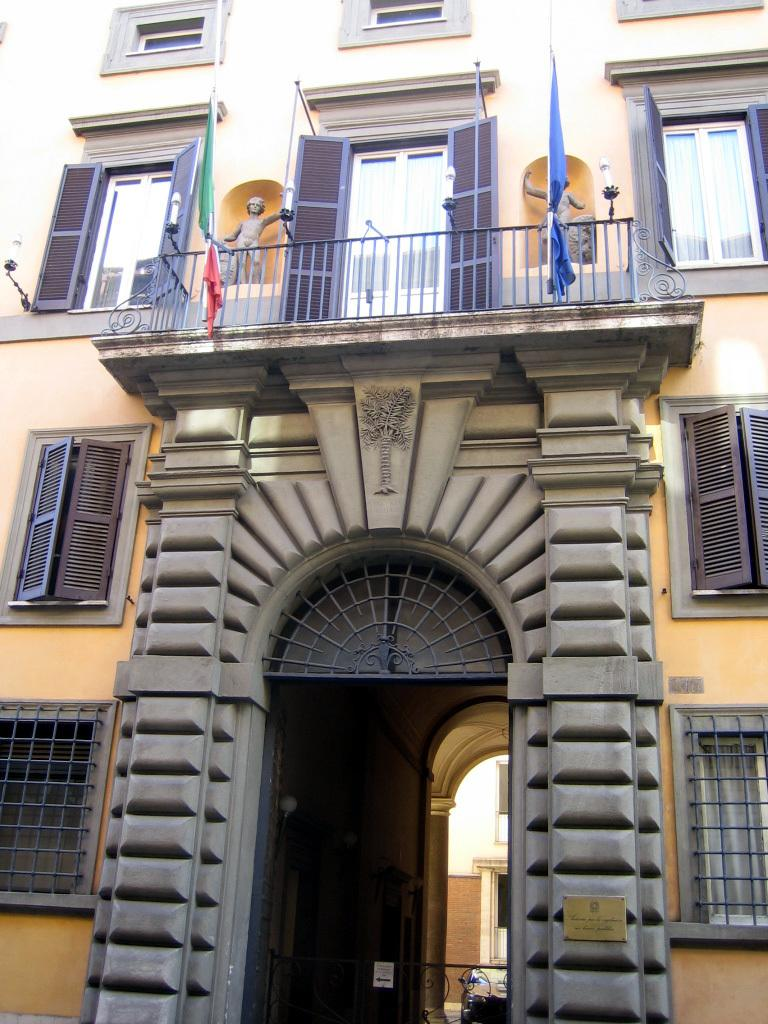What can be seen in the foreground of the image? In the foreground of the image, there are windows, an entrance, sculptures, and flags. Can you describe the windows in the image? The windows are located in the foreground of the image. What type of architectural feature is the entrance in the image? The entrance is an architectural feature in the foreground of the image. What kind of objects are the sculptures in the image? The sculptures are objects in the foreground of the image. What else is present in the foreground of the image besides the windows, entrance, and sculptures? There are flags in the foreground of the image. Where is the maid located in the image? There is no maid present in the image. What type of vehicle is parked near the entrance in the image? There is no vehicle present in the image. 